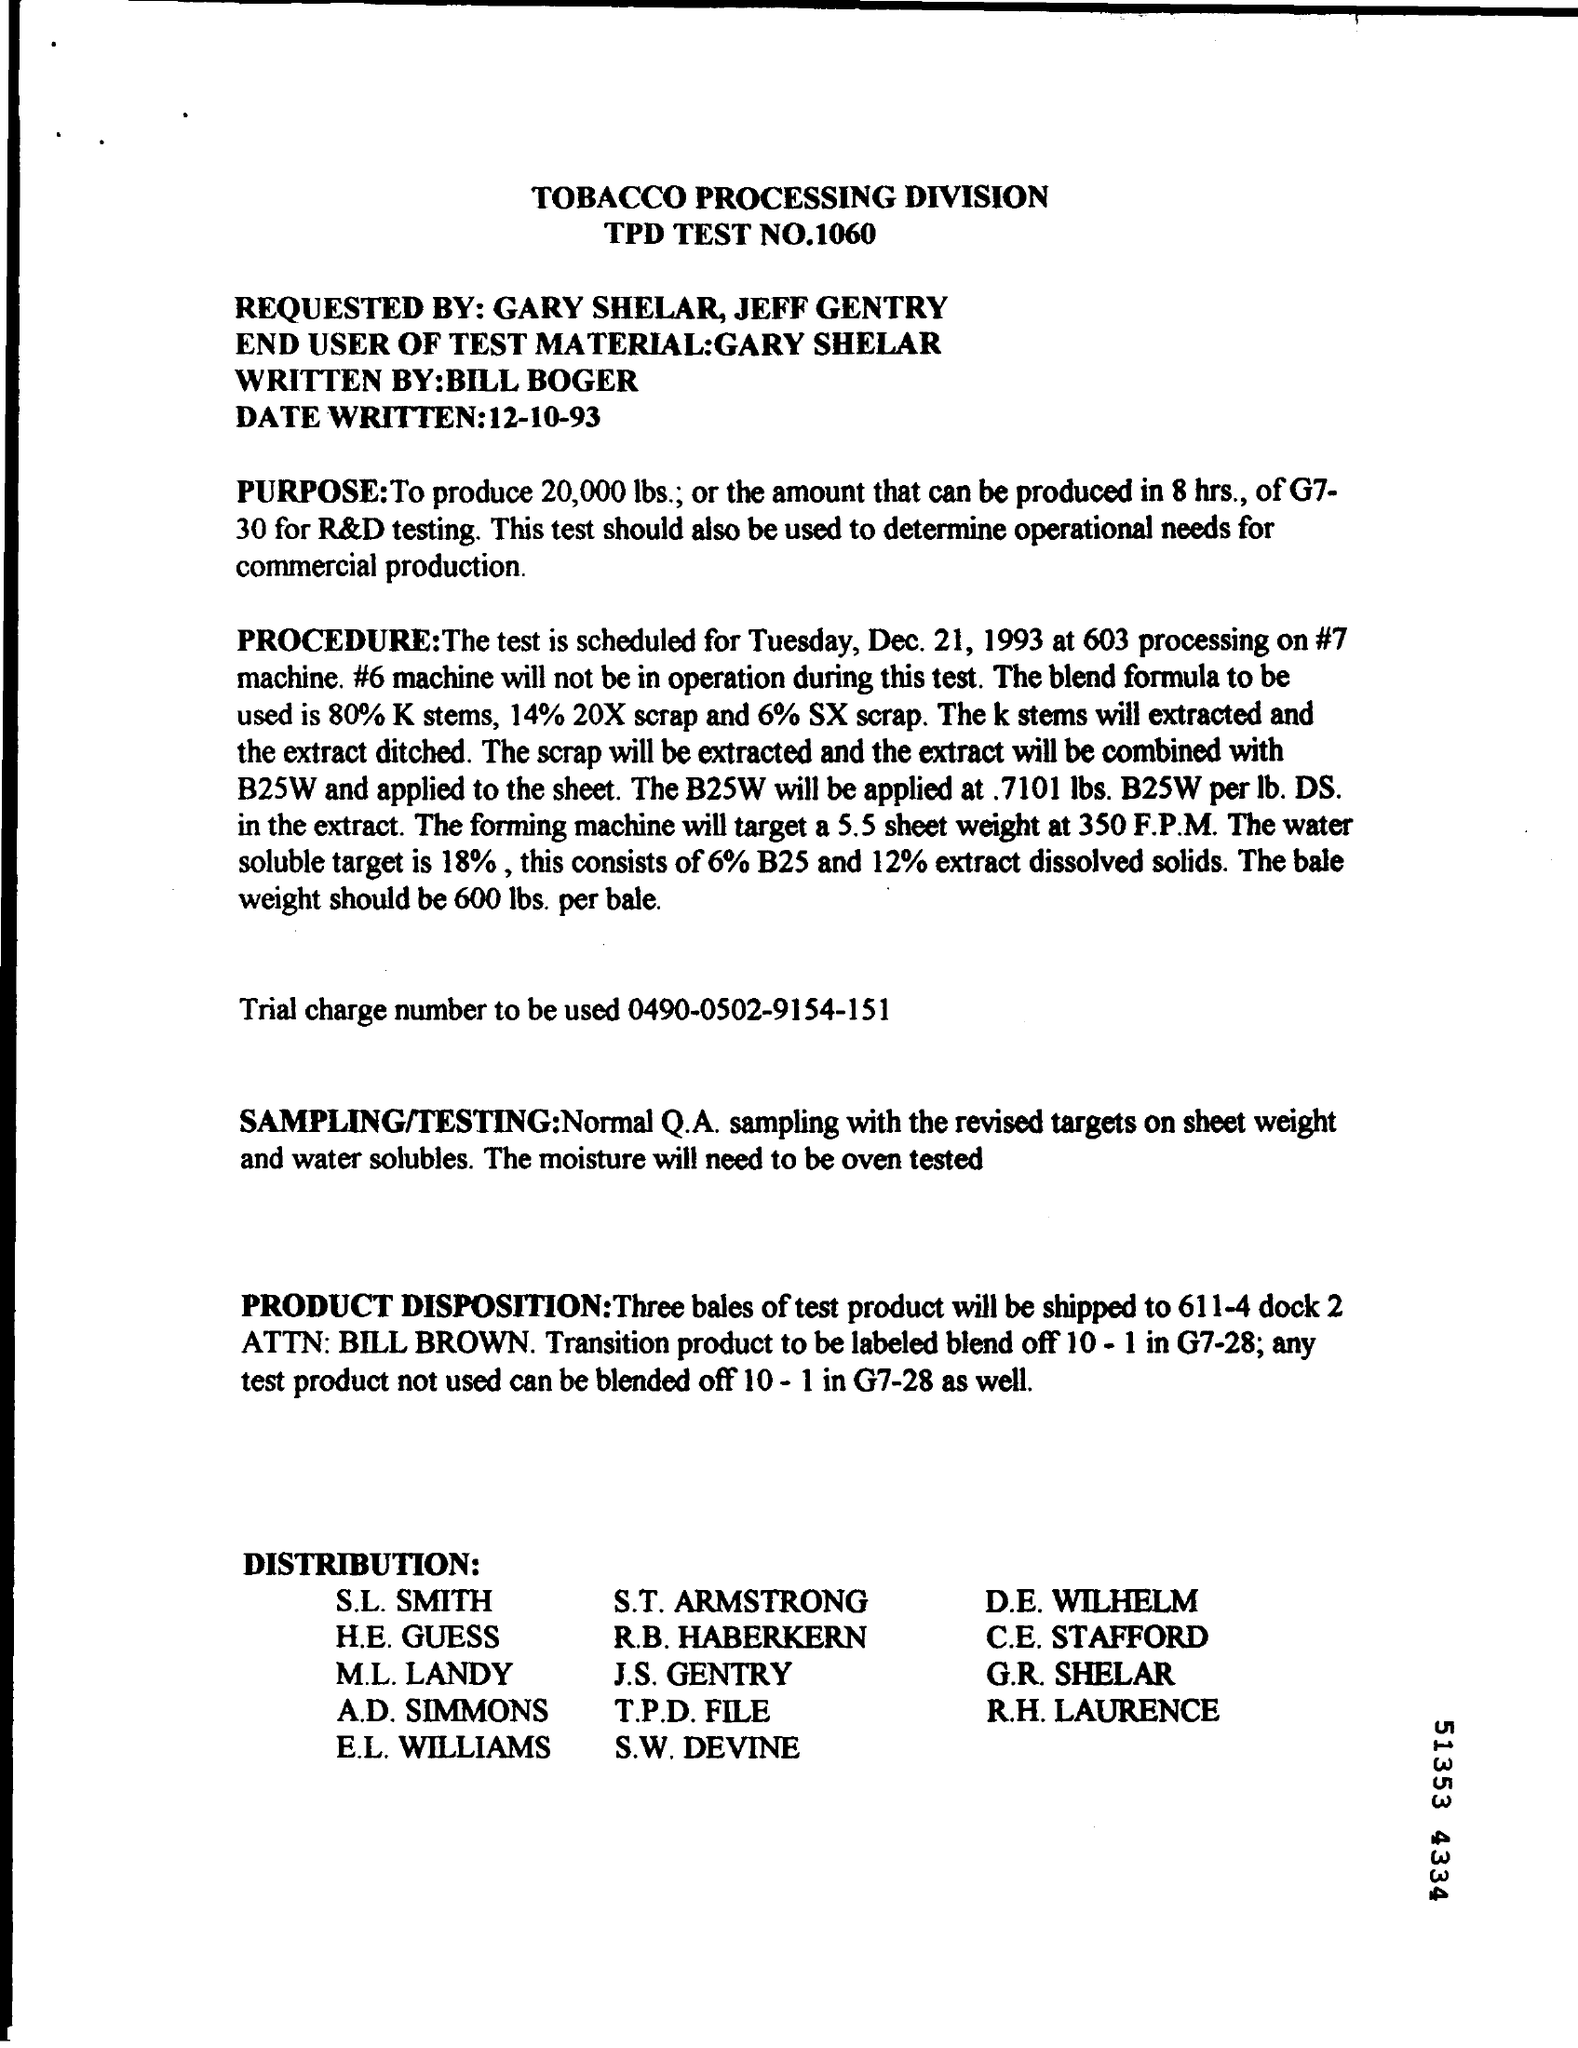What is the TPD TEST NO ?
Your answer should be compact. 1060. What is the Trial Charge Number ?
Your response must be concise. 0490-0502-9154-151. 